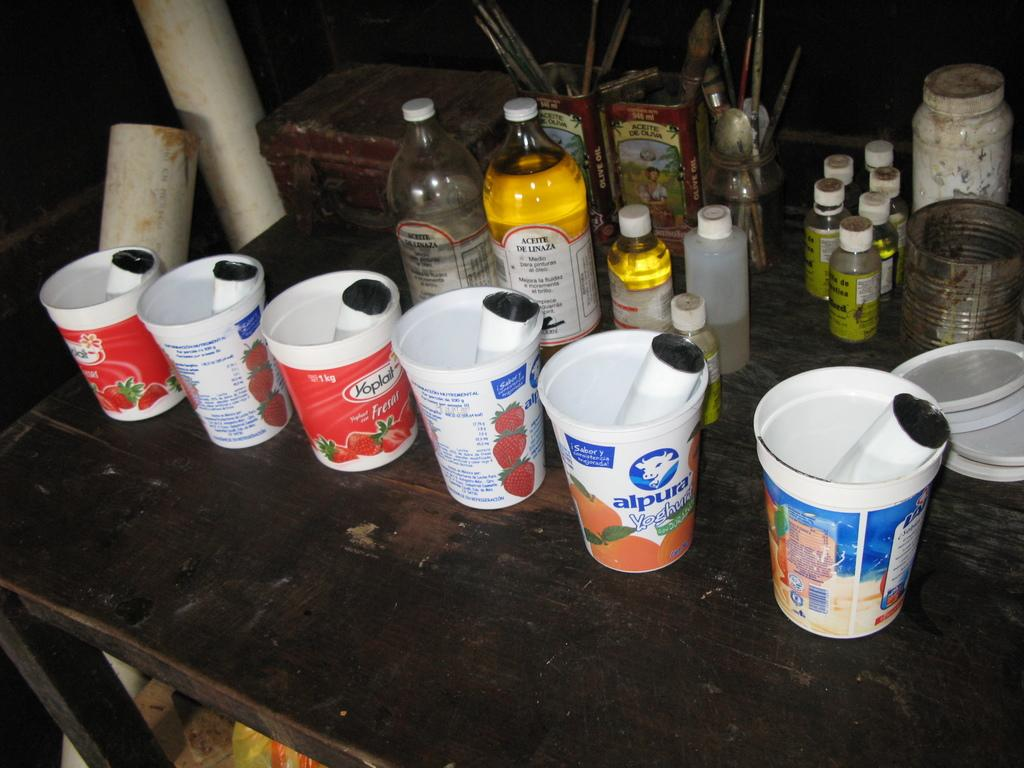<image>
Summarize the visual content of the image. Several open bottle next to yoplait yogurt containers. 